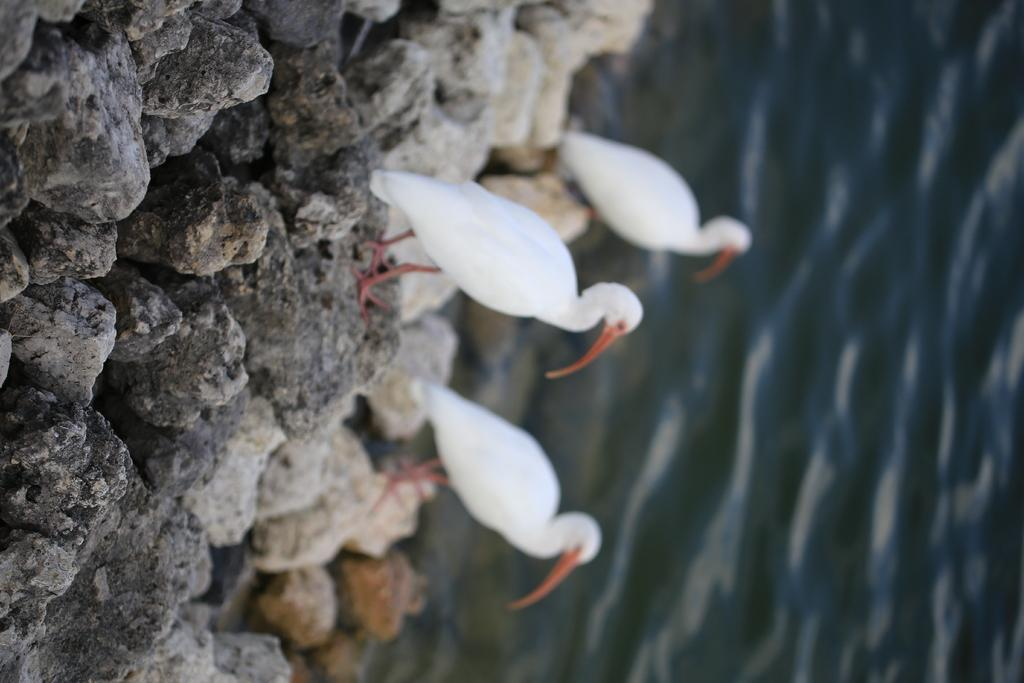How many birds are in the image? There are three birds in the image. What are the birds standing on? The birds are standing on stones. What can be seen on the right side of the image? There is water on the right side of the image. What type of star can be seen in the image? There is no star present in the image; it features three birds standing on stones with water on the right side. 